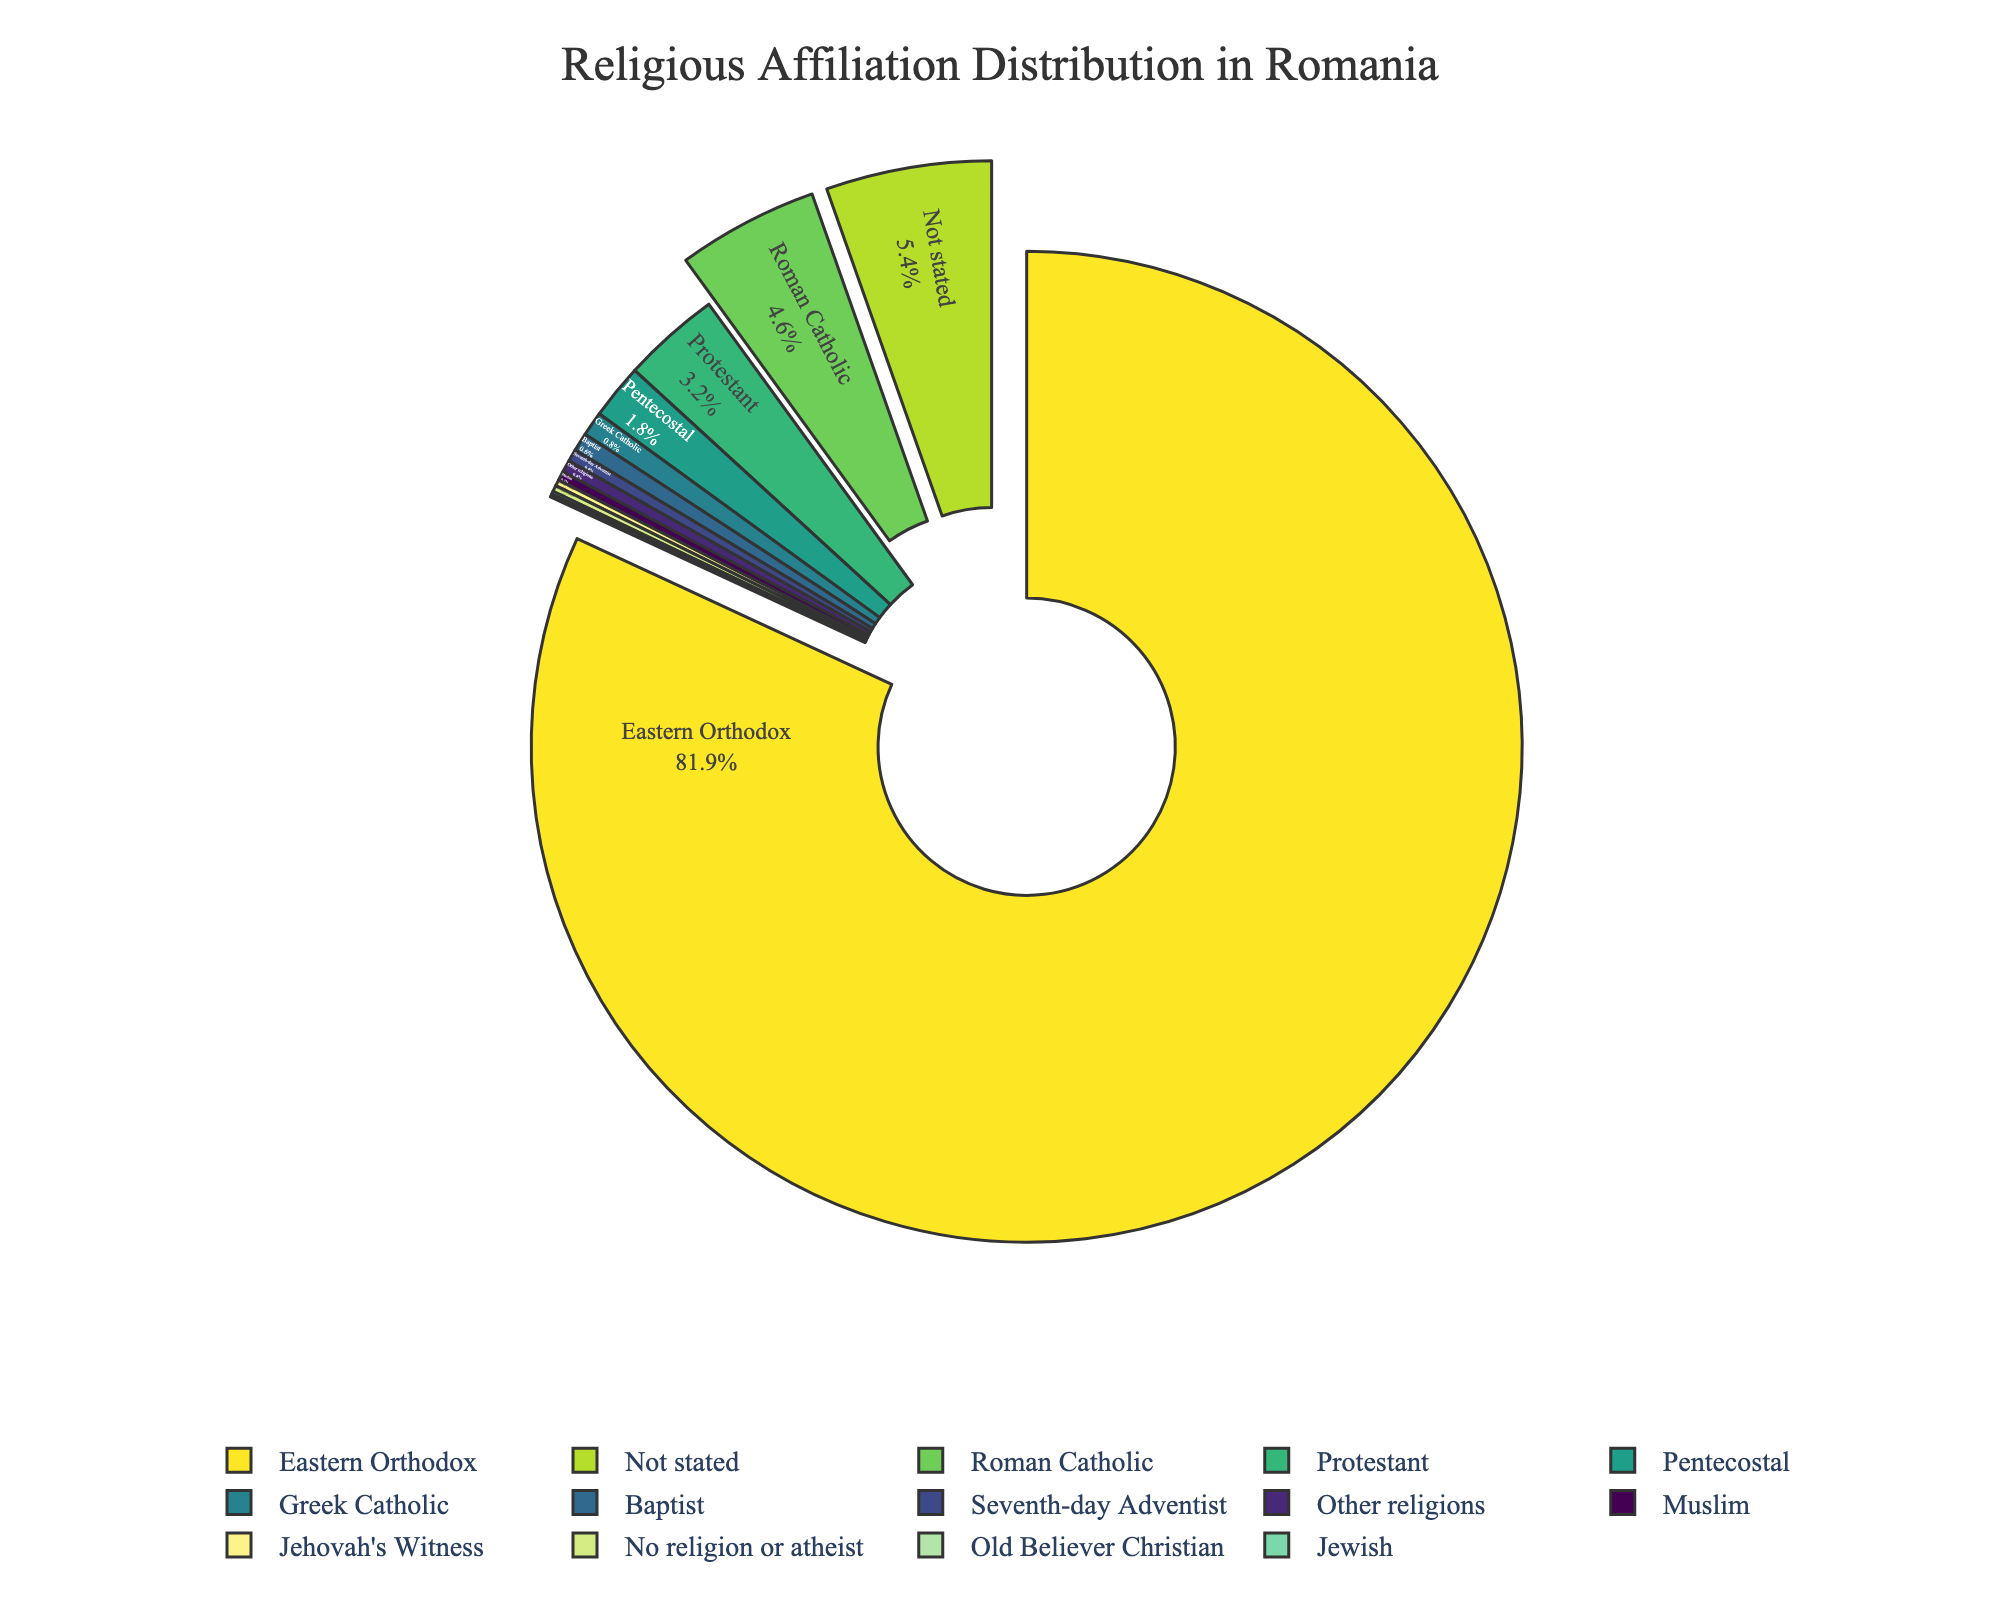What is the largest religious denomination in Romania according to the pie chart? By looking at the pie chart, identify the slice that occupies the largest area. The label on this slice will indicate the largest denomination, which is Eastern Orthodox, covering 81.9%.
Answer: Eastern Orthodox Which religious denomination accounts for the smallest percentage? Refer to the smallest slice in the pie chart. The label on this slice indicates either Jewish or Old Believer Christian, both covering 0.1%.
Answer: Jewish or Old Believer Christian What percentage of the population either follows Pentecostalism or has no religion/atheist? Identify the slices for Pentecostal (1.8%) and No religion or atheist (0.2%). Sum these percentages: 1.8% + 0.2% = 2.0%
Answer: 2.0% Is the percentage of Roman Catholics more or less than 5%? Find the Roman Catholic slice, which is labeled with its percentage. It is 4.6%, which is less than 5%.
Answer: Less than 5% Which non-Christian religion has the largest percentage? Locate the slices for non-Christian religions: Muslim (0.3%) and Jewish (0.1%). The Muslim slice is larger at 0.3%.
Answer: Muslim How many religious denominations have a percentage interpretation marked within their slice in the pie chart? By visually inspecting the pie chart, count the slices that have percentages written inside them. All slices have percentages, which totals to 14 denominations.
Answer: 14 Compare the combined percentage of Protestant and Greek Catholic to that of Roman Catholic. Which is higher? Sum the percentages of Protestant (3.2%) and Greek Catholic (0.8%), which gives 4.0%. Compare 4.0% with Roman Catholic (4.6%). Roman Catholic is higher.
Answer: Roman Catholic What is the combined percentage of Protestant, Greek Catholic, Pentecostal, and Baptist denominations? Sum the percentages of Protestant (3.2%), Greek Catholic (0.8%), Pentecostal (1.8%), and Baptist (0.6%): 3.2% + 0.8% + 1.8% + 0.6% = 6.4%
Answer: 6.4% Are there any religious denominations with the same percentage of followers? If so, which ones? Check for slices with identical percentages. Jewish and Old Believer Christian both show 0.1%.
Answer: Jewish and Old Believer Christian How does the percentage of the "Not stated" category compare to that of all Protestant denominations combined? Identify the "Not stated" slice (5.4%) and add up all Protestant denominations (3.2% Protestant + 0.8% Greek Catholic + 1.8% Pentecostal + 0.6% Baptist + 0.4% Seventh-day Adventist + 0.2% Jehovah's Witness + 0.1% Old Believer Christian = 7.1%). 5.4% is less than 7.1%.
Answer: Less than 7.1% 